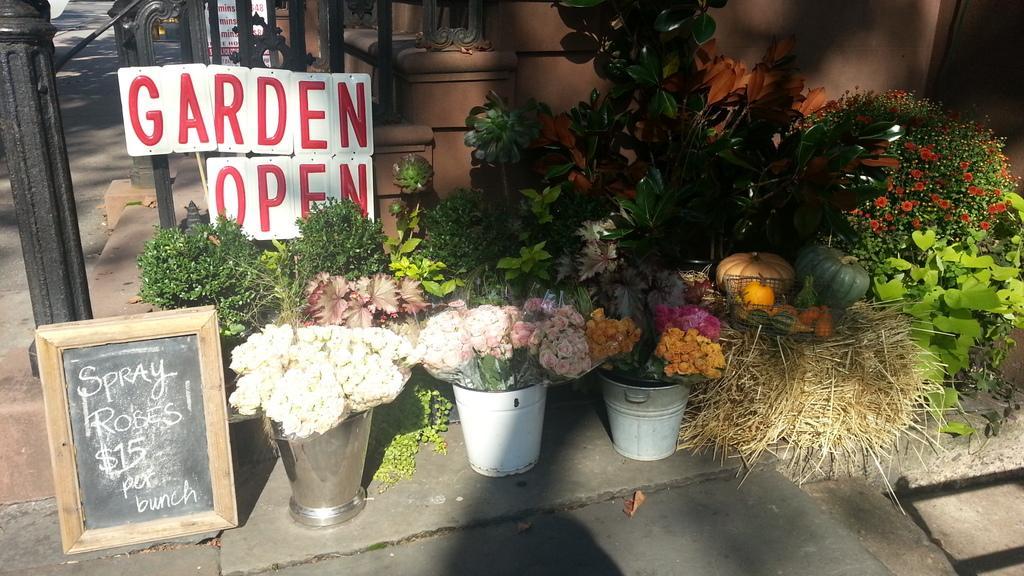Describe this image in one or two sentences. Here in this picture we can see plants and flower bouquets present in basket, present on the ground over there and we can see a board present on the left side and we can see pole and steps present behind that over there. 